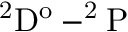Convert formula to latex. <formula><loc_0><loc_0><loc_500><loc_500>^ { 2 } D ^ { o } - ^ { 2 } P</formula> 